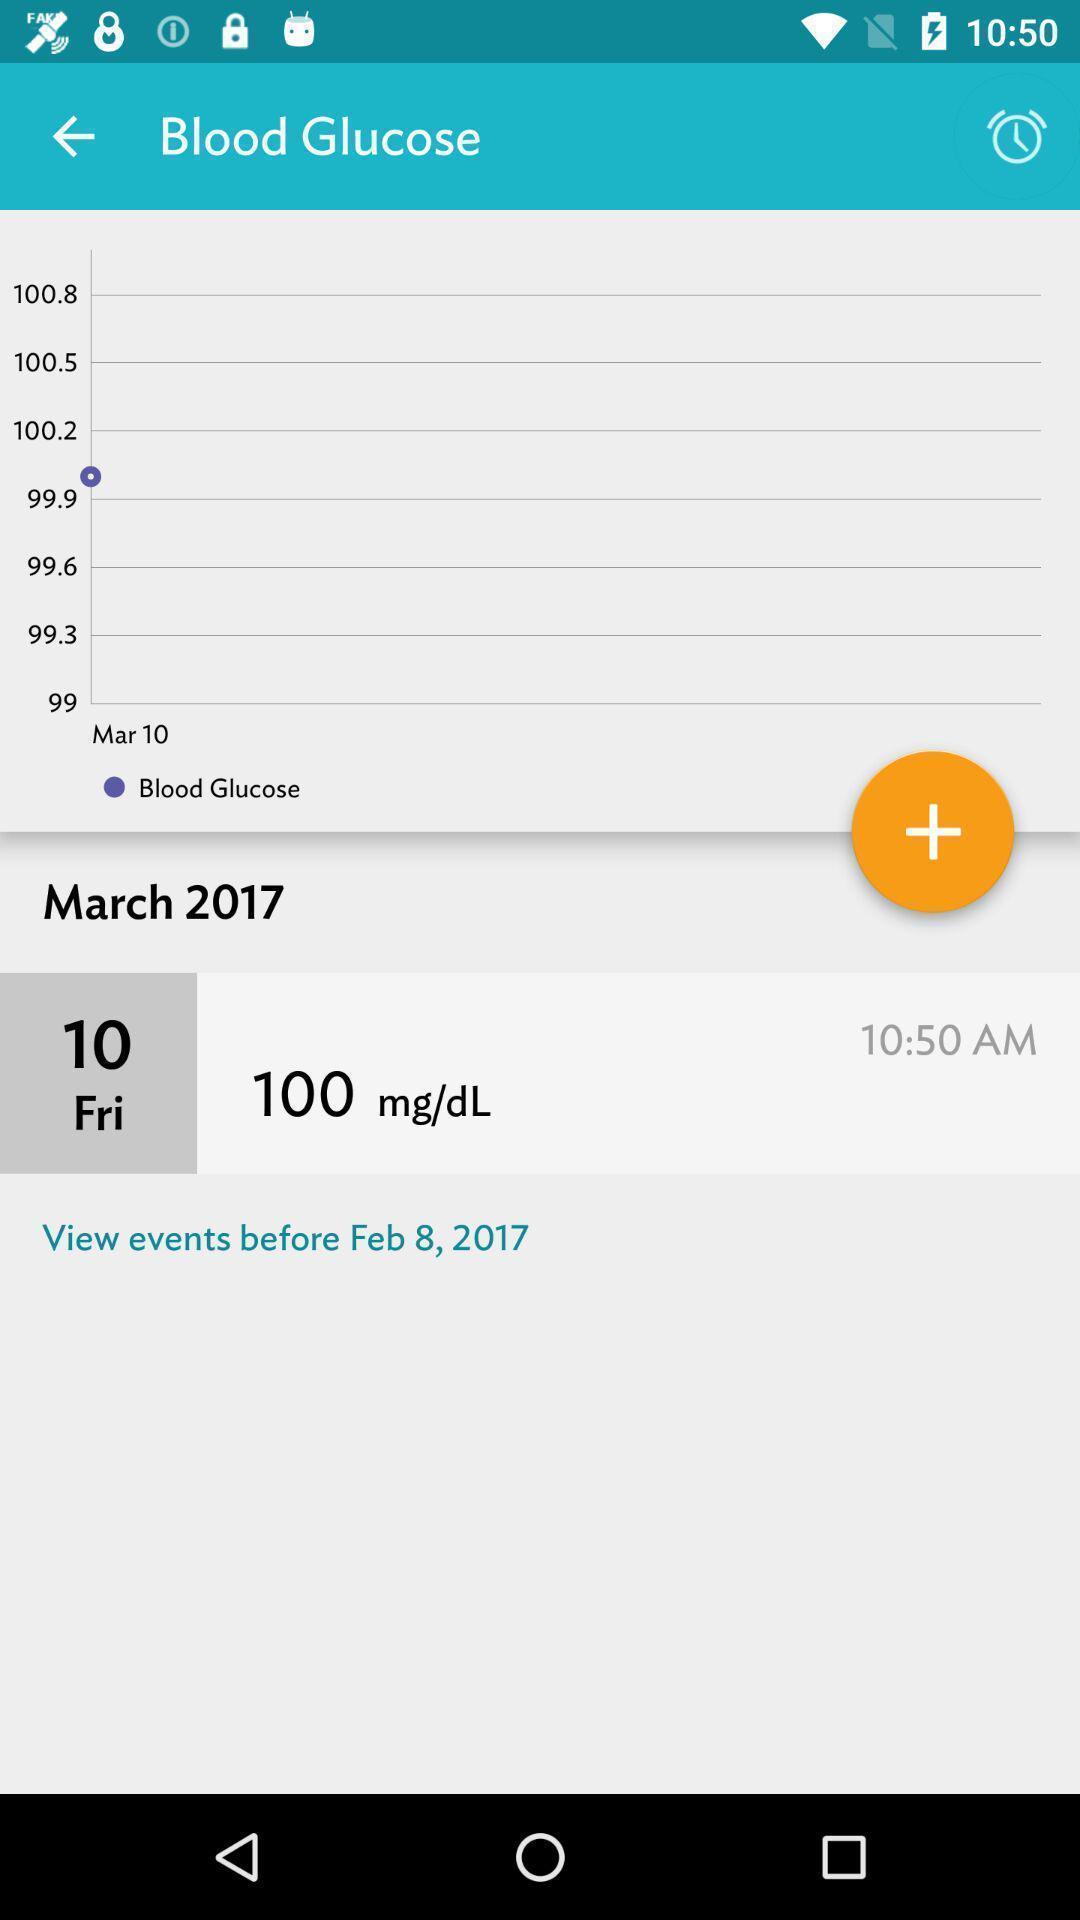Explain the elements present in this screenshot. Page showing blood glucose levels in a health app. 